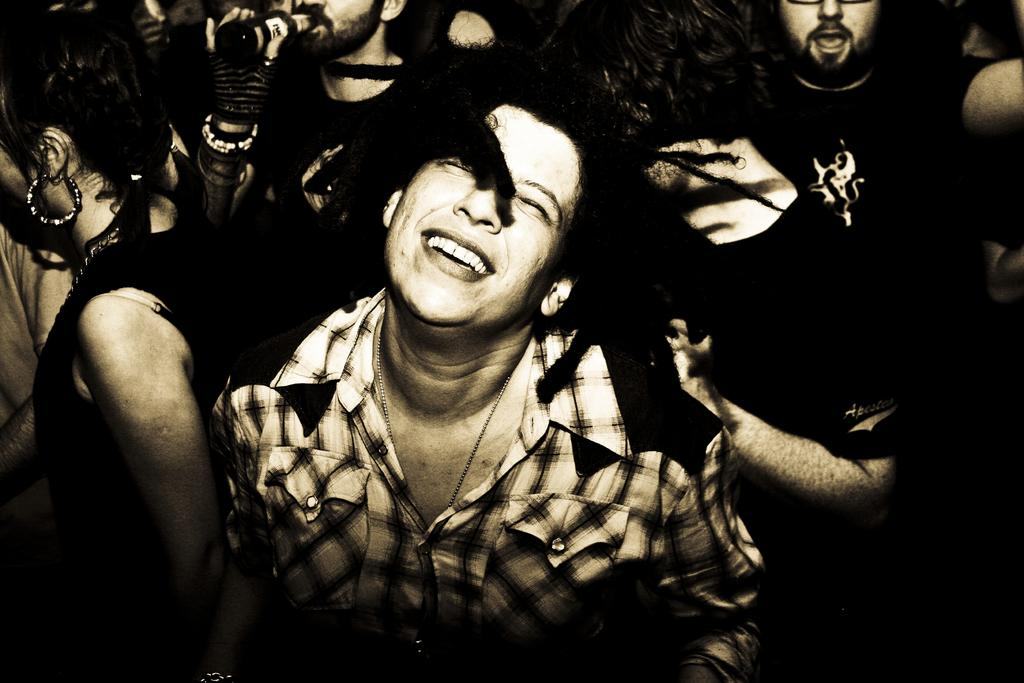How many people are in the image? There is a group of persons in the image. Can you describe the action of one of the persons in the image? There is a person holding a bottle at the top of the image. What type of destruction can be seen in the image? There is no destruction present in the image; it features a group of persons and a person holding a bottle. How many chairs are visible in the image? There is no mention of chairs in the image, so it cannot be determined how many are present. 